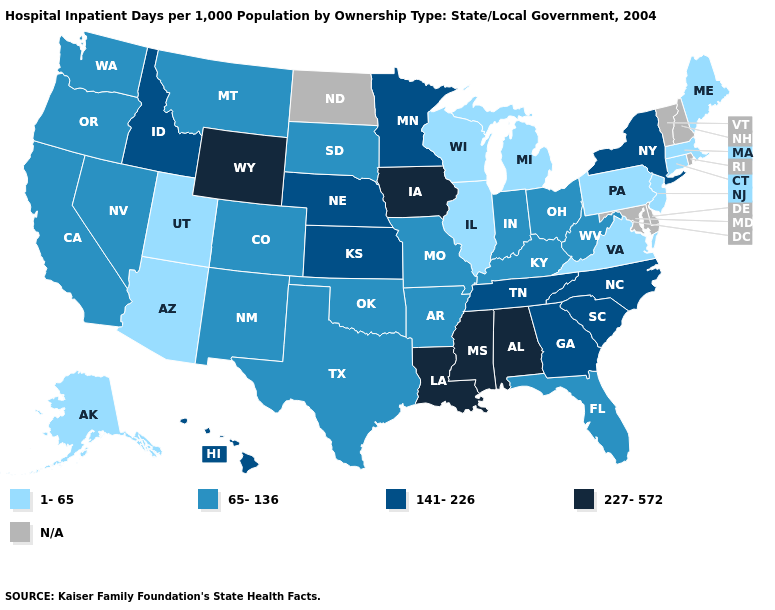Does Pennsylvania have the lowest value in the USA?
Be succinct. Yes. Name the states that have a value in the range 65-136?
Quick response, please. Arkansas, California, Colorado, Florida, Indiana, Kentucky, Missouri, Montana, Nevada, New Mexico, Ohio, Oklahoma, Oregon, South Dakota, Texas, Washington, West Virginia. Does Iowa have the highest value in the USA?
Give a very brief answer. Yes. What is the value of New Hampshire?
Be succinct. N/A. Does Minnesota have the lowest value in the USA?
Quick response, please. No. Which states hav the highest value in the MidWest?
Short answer required. Iowa. What is the value of Nevada?
Answer briefly. 65-136. Among the states that border Kentucky , does Missouri have the lowest value?
Keep it brief. No. What is the value of Oregon?
Be succinct. 65-136. What is the value of Indiana?
Quick response, please. 65-136. What is the highest value in states that border Maryland?
Give a very brief answer. 65-136. Which states have the lowest value in the USA?
Keep it brief. Alaska, Arizona, Connecticut, Illinois, Maine, Massachusetts, Michigan, New Jersey, Pennsylvania, Utah, Virginia, Wisconsin. Among the states that border New Jersey , which have the lowest value?
Write a very short answer. Pennsylvania. 